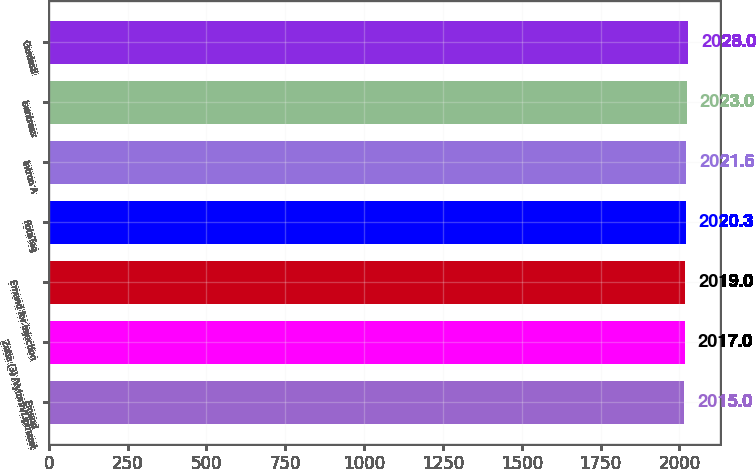Convert chart to OTSL. <chart><loc_0><loc_0><loc_500><loc_500><bar_chart><fcel>Emend<fcel>Zetia (3) /Vytorin/Liptruzet<fcel>Emend for Injection<fcel>RotaTeq<fcel>Intron A<fcel>Isentress<fcel>Gardasil<nl><fcel>2015<fcel>2017<fcel>2019<fcel>2020.3<fcel>2021.6<fcel>2023<fcel>2028<nl></chart> 